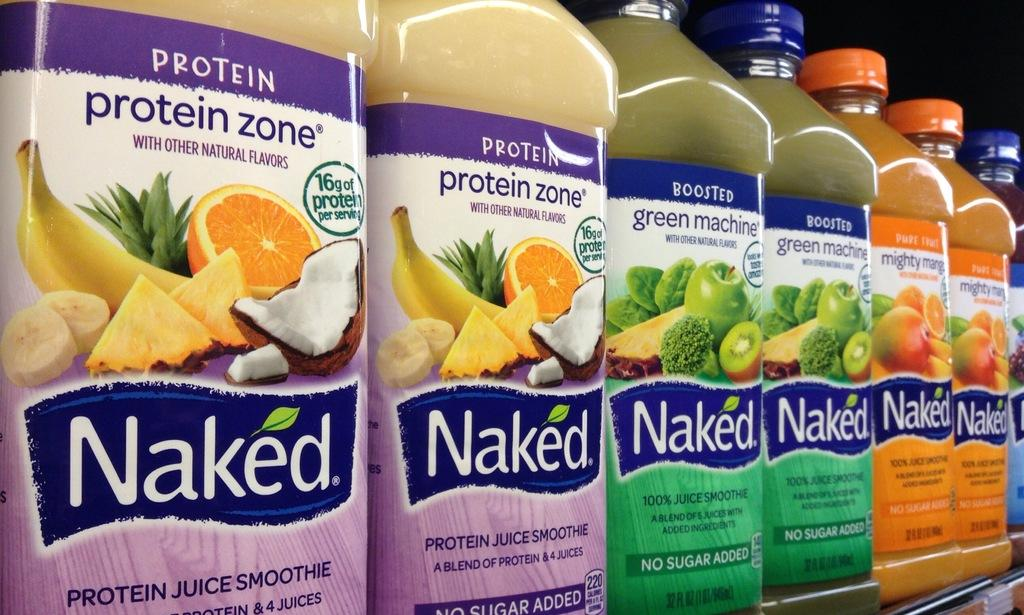What objects can be seen in the image? There are bottles in the image. What is inside the bottles? There are food items in the bottles. Are there any plants growing in the bottles in the image? No, there are no plants growing in the bottles in the image. 